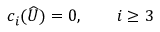<formula> <loc_0><loc_0><loc_500><loc_500>c _ { i } ( \widehat { U } ) = 0 , \quad i \geq 3</formula> 